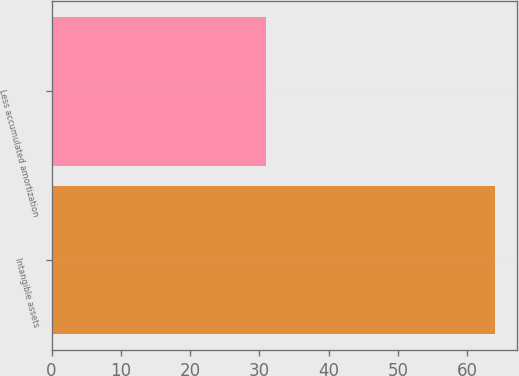Convert chart. <chart><loc_0><loc_0><loc_500><loc_500><bar_chart><fcel>Intangible assets<fcel>Less accumulated amortization<nl><fcel>64<fcel>31<nl></chart> 